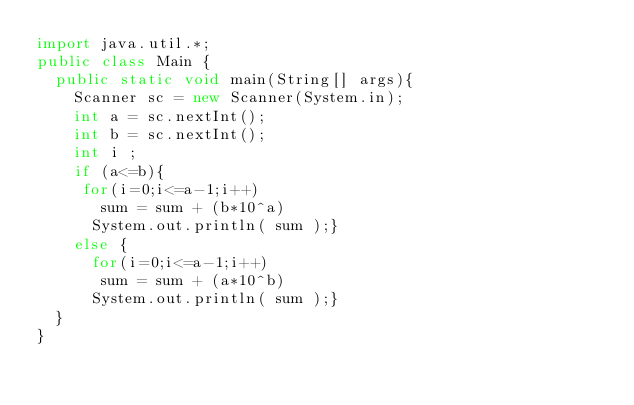<code> <loc_0><loc_0><loc_500><loc_500><_Java_>import java.util.*;
public class Main {
  public static void main(String[] args){
    Scanner sc = new Scanner(System.in);
    int a = sc.nextInt();
    int b = sc.nextInt();
    int i ;
    if (a<=b){
     for(i=0;i<=a-1;i++)
       sum = sum + (b*10^a)
      System.out.println( sum );}
    else {
      for(i=0;i<=a-1;i++)
       sum = sum + (a*10^b)
      System.out.println( sum );}
  }
}</code> 